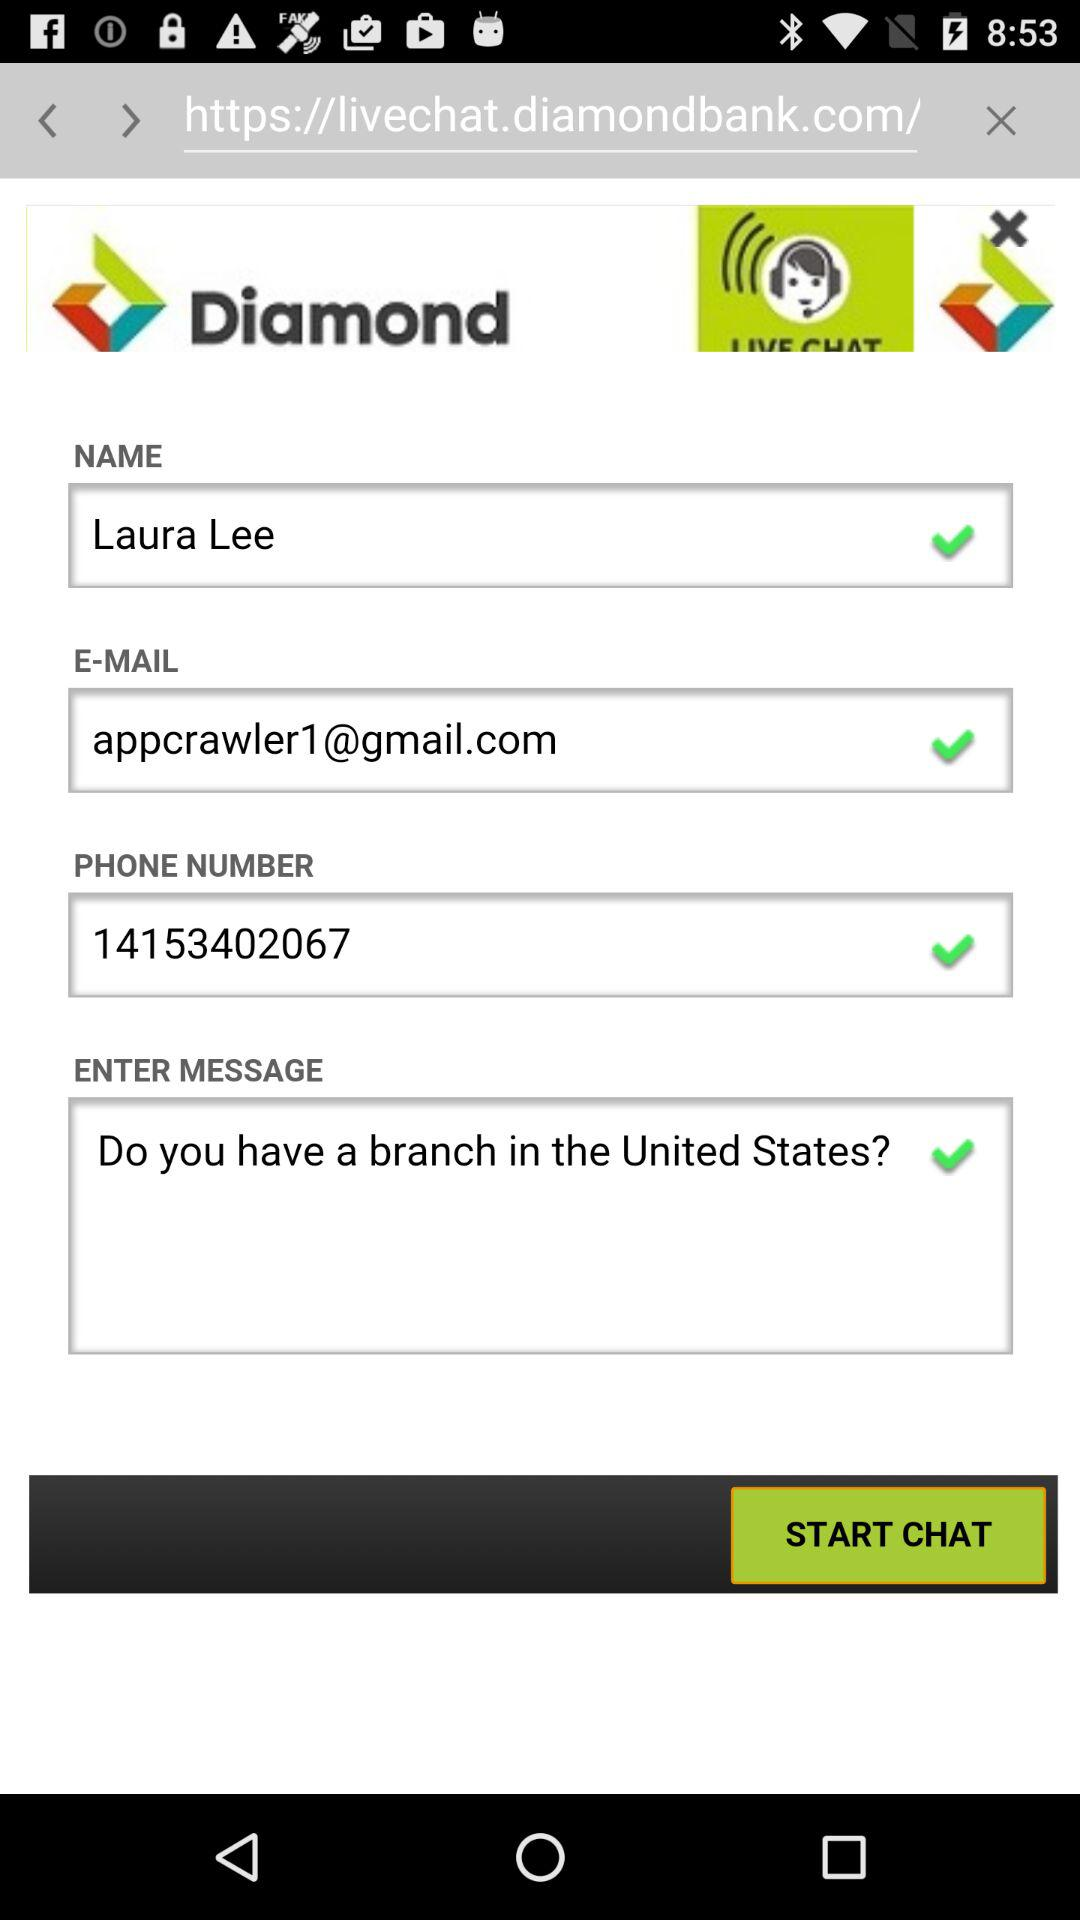What is the written text in the "Enter Message" box? The written text is "Do you have a branch in the United States?". 